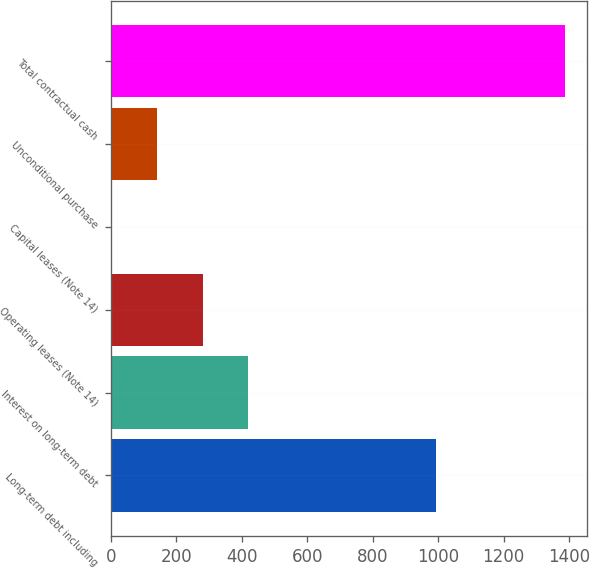<chart> <loc_0><loc_0><loc_500><loc_500><bar_chart><fcel>Long-term debt including<fcel>Interest on long-term debt<fcel>Operating leases (Note 14)<fcel>Capital leases (Note 14)<fcel>Unconditional purchase<fcel>Total contractual cash<nl><fcel>993<fcel>418.6<fcel>280.4<fcel>4<fcel>142.2<fcel>1386<nl></chart> 